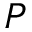<formula> <loc_0><loc_0><loc_500><loc_500>P</formula> 